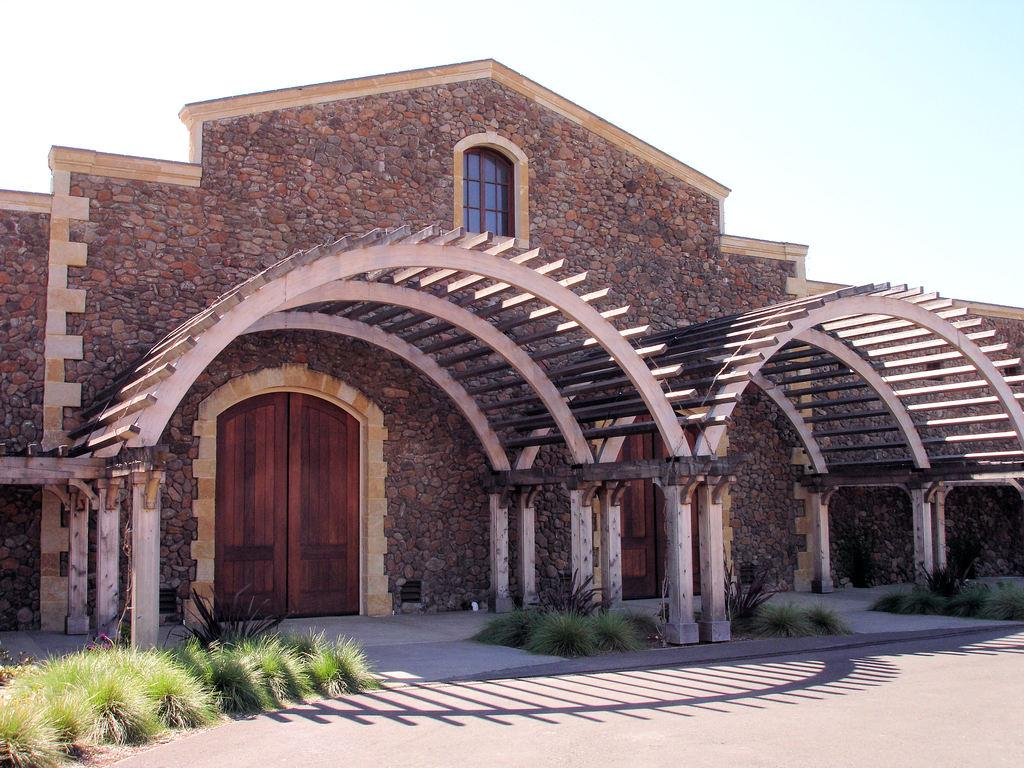What type of structure is visible in the image? There is a house in the image. What can be seen in front of the house? There are plants in front of the house. How many mice are hiding among the lettuce in the image? There are no mice or lettuce present in the image. What type of fan is visible in the image? There is no fan present in the image. 